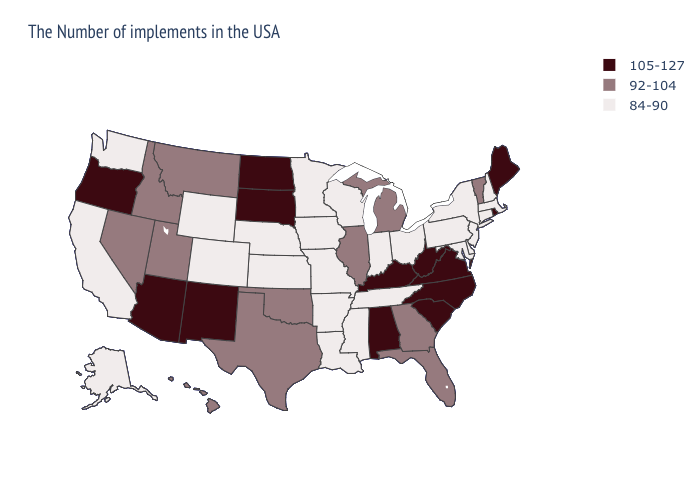What is the value of Arkansas?
Short answer required. 84-90. Does the first symbol in the legend represent the smallest category?
Write a very short answer. No. Name the states that have a value in the range 92-104?
Be succinct. Vermont, Florida, Georgia, Michigan, Illinois, Oklahoma, Texas, Utah, Montana, Idaho, Nevada, Hawaii. Name the states that have a value in the range 84-90?
Concise answer only. Massachusetts, New Hampshire, Connecticut, New York, New Jersey, Delaware, Maryland, Pennsylvania, Ohio, Indiana, Tennessee, Wisconsin, Mississippi, Louisiana, Missouri, Arkansas, Minnesota, Iowa, Kansas, Nebraska, Wyoming, Colorado, California, Washington, Alaska. Name the states that have a value in the range 84-90?
Give a very brief answer. Massachusetts, New Hampshire, Connecticut, New York, New Jersey, Delaware, Maryland, Pennsylvania, Ohio, Indiana, Tennessee, Wisconsin, Mississippi, Louisiana, Missouri, Arkansas, Minnesota, Iowa, Kansas, Nebraska, Wyoming, Colorado, California, Washington, Alaska. Is the legend a continuous bar?
Concise answer only. No. Which states have the lowest value in the USA?
Keep it brief. Massachusetts, New Hampshire, Connecticut, New York, New Jersey, Delaware, Maryland, Pennsylvania, Ohio, Indiana, Tennessee, Wisconsin, Mississippi, Louisiana, Missouri, Arkansas, Minnesota, Iowa, Kansas, Nebraska, Wyoming, Colorado, California, Washington, Alaska. Name the states that have a value in the range 84-90?
Be succinct. Massachusetts, New Hampshire, Connecticut, New York, New Jersey, Delaware, Maryland, Pennsylvania, Ohio, Indiana, Tennessee, Wisconsin, Mississippi, Louisiana, Missouri, Arkansas, Minnesota, Iowa, Kansas, Nebraska, Wyoming, Colorado, California, Washington, Alaska. What is the lowest value in the West?
Short answer required. 84-90. Does New Hampshire have the same value as Oregon?
Quick response, please. No. Which states have the highest value in the USA?
Short answer required. Maine, Rhode Island, Virginia, North Carolina, South Carolina, West Virginia, Kentucky, Alabama, South Dakota, North Dakota, New Mexico, Arizona, Oregon. What is the value of Arizona?
Write a very short answer. 105-127. What is the lowest value in states that border Connecticut?
Keep it brief. 84-90. Does Arkansas have the highest value in the South?
Answer briefly. No. Is the legend a continuous bar?
Quick response, please. No. 